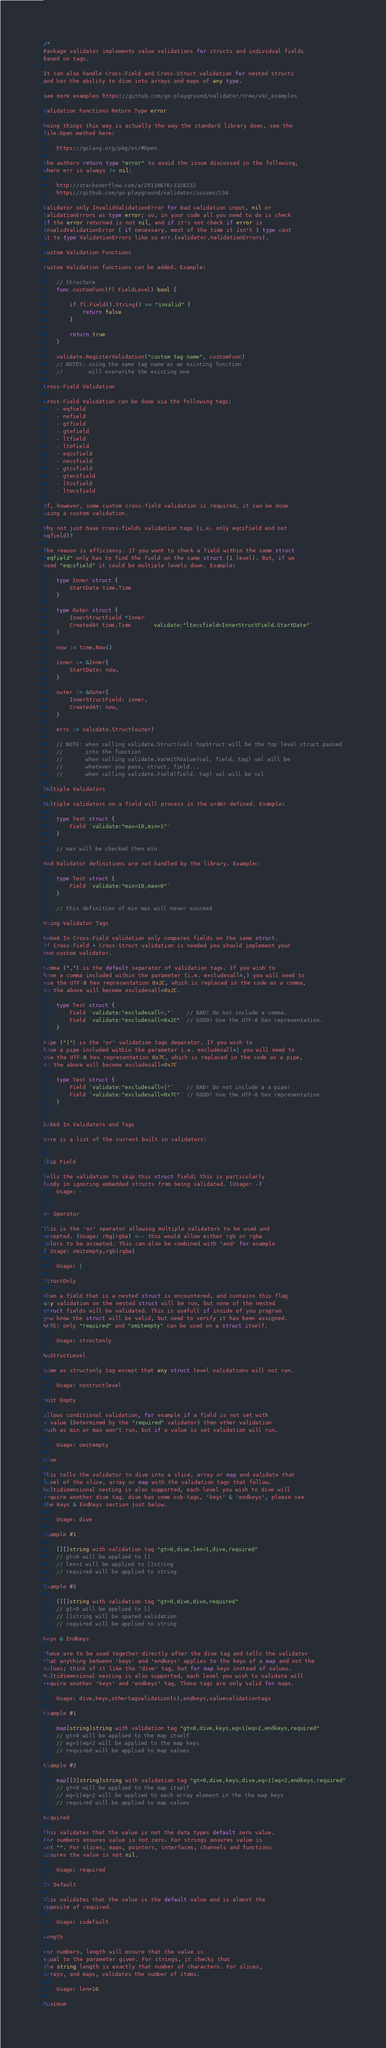<code> <loc_0><loc_0><loc_500><loc_500><_Go_>/*
Package validator implements value validations for structs and individual fields
based on tags.

It can also handle Cross-Field and Cross-Struct validation for nested structs
and has the ability to dive into arrays and maps of any type.

see more examples https://github.com/go-playground/validator/tree/v9/_examples

Validation Functions Return Type error

Doing things this way is actually the way the standard library does, see the
file.Open method here:

	https://golang.org/pkg/os/#Open.

The authors return type "error" to avoid the issue discussed in the following,
where err is always != nil:

	http://stackoverflow.com/a/29138676/3158232
	https://github.com/go-playground/validator/issues/134

Validator only InvalidValidationError for bad validation input, nil or
ValidationErrors as type error; so, in your code all you need to do is check
if the error returned is not nil, and if it's not check if error is
InvalidValidationError ( if necessary, most of the time it isn't ) type cast
it to type ValidationErrors like so err.(validator.ValidationErrors).

Custom Validation Functions

Custom Validation functions can be added. Example:

	// Structure
	func customFunc(fl FieldLevel) bool {

		if fl.Field().String() == "invalid" {
			return false
		}

		return true
	}

	validate.RegisterValidation("custom tag name", customFunc)
	// NOTES: using the same tag name as an existing function
	//        will overwrite the existing one

Cross-Field Validation

Cross-Field Validation can be done via the following tags:
	- eqfield
	- nefield
	- gtfield
	- gtefield
	- ltfield
	- ltefield
	- eqcsfield
	- necsfield
	- gtcsfield
	- gtecsfield
	- ltcsfield
	- ltecsfield

If, however, some custom cross-field validation is required, it can be done
using a custom validation.

Why not just have cross-fields validation tags (i.e. only eqcsfield and not
eqfield)?

The reason is efficiency. If you want to check a field within the same struct
"eqfield" only has to find the field on the same struct (1 level). But, if we
used "eqcsfield" it could be multiple levels down. Example:

	type Inner struct {
		StartDate time.Time
	}

	type Outer struct {
		InnerStructField *Inner
		CreatedAt time.Time      `validate:"ltecsfield=InnerStructField.StartDate"`
	}

	now := time.Now()

	inner := &Inner{
		StartDate: now,
	}

	outer := &Outer{
		InnerStructField: inner,
		CreatedAt: now,
	}

	errs := validate.Struct(outer)

	// NOTE: when calling validate.Struct(val) topStruct will be the top level struct passed
	//       into the function
	//       when calling validate.VarWithValue(val, field, tag) val will be
	//       whatever you pass, struct, field...
	//       when calling validate.Field(field, tag) val will be nil

Multiple Validators

Multiple validators on a field will process in the order defined. Example:

	type Test struct {
		Field `validate:"max=10,min=1"`
	}

	// max will be checked then min

Bad Validator definitions are not handled by the library. Example:

	type Test struct {
		Field `validate:"min=10,max=0"`
	}

	// this definition of min max will never succeed

Using Validator Tags

Baked In Cross-Field validation only compares fields on the same struct.
If Cross-Field + Cross-Struct validation is needed you should implement your
own custom validator.

Comma (",") is the default separator of validation tags. If you wish to
have a comma included within the parameter (i.e. excludesall=,) you will need to
use the UTF-8 hex representation 0x2C, which is replaced in the code as a comma,
so the above will become excludesall=0x2C.

	type Test struct {
		Field `validate:"excludesall=,"`    // BAD! Do not include a comma.
		Field `validate:"excludesall=0x2C"` // GOOD! Use the UTF-8 hex representation.
	}

Pipe ("|") is the 'or' validation tags deparator. If you wish to
have a pipe included within the parameter i.e. excludesall=| you will need to
use the UTF-8 hex representation 0x7C, which is replaced in the code as a pipe,
so the above will become excludesall=0x7C

	type Test struct {
		Field `validate:"excludesall=|"`    // BAD! Do not include a a pipe!
		Field `validate:"excludesall=0x7C"` // GOOD! Use the UTF-8 hex representation.
	}


Baked In Validators and Tags

Here is a list of the current built in validators:


Skip Field

Tells the validation to skip this struct field; this is particularly
handy in ignoring embedded structs from being validated. (Usage: -)
	Usage: -


Or Operator

This is the 'or' operator allowing multiple validators to be used and
accepted. (Usage: rbg|rgba) <-- this would allow either rgb or rgba
colors to be accepted. This can also be combined with 'and' for example
( Usage: omitempty,rgb|rgba)

	Usage: |

StructOnly

When a field that is a nested struct is encountered, and contains this flag
any validation on the nested struct will be run, but none of the nested
struct fields will be validated. This is usefull if inside of you program
you know the struct will be valid, but need to verify it has been assigned.
NOTE: only "required" and "omitempty" can be used on a struct itself.

	Usage: structonly

NoStructLevel

Same as structonly tag except that any struct level validations will not run.

	Usage: nostructlevel

Omit Empty

Allows conditional validation, for example if a field is not set with
a value (Determined by the "required" validator) then other validation
such as min or max won't run, but if a value is set validation will run.

	Usage: omitempty

Dive

This tells the validator to dive into a slice, array or map and validate that
level of the slice, array or map with the validation tags that follow.
Multidimensional nesting is also supported, each level you wish to dive will
require another dive tag. dive has some sub-tags, 'keys' & 'endkeys', please see
the Keys & EndKeys section just below.

	Usage: dive

Example #1

	[][]string with validation tag "gt=0,dive,len=1,dive,required"
	// gt=0 will be applied to []
	// len=1 will be applied to []string
	// required will be applied to string

Example #2

	[][]string with validation tag "gt=0,dive,dive,required"
	// gt=0 will be applied to []
	// []string will be spared validation
	// required will be applied to string

Keys & EndKeys

These are to be used together directly after the dive tag and tells the validator
that anything between 'keys' and 'endkeys' applies to the keys of a map and not the
values; think of it like the 'dive' tag, but for map keys instead of values.
Multidimensional nesting is also supported, each level you wish to validate will
require another 'keys' and 'endkeys' tag. These tags are only valid for maps.

	Usage: dive,keys,othertagvalidation(s),endkeys,valuevalidationtags

Example #1

	map[string]string with validation tag "gt=0,dive,keys,eg=1|eq=2,endkeys,required"
	// gt=0 will be applied to the map itself
	// eg=1|eq=2 will be applied to the map keys
	// required will be applied to map values

Example #2

	map[[2]string]string with validation tag "gt=0,dive,keys,dive,eq=1|eq=2,endkeys,required"
	// gt=0 will be applied to the map itself
	// eg=1|eq=2 will be applied to each array element in the the map keys
	// required will be applied to map values

Required

This validates that the value is not the data types default zero value.
For numbers ensures value is not zero. For strings ensures value is
not "". For slices, maps, pointers, interfaces, channels and functions
ensures the value is not nil.

	Usage: required

Is Default

This validates that the value is the default value and is almost the
opposite of required.

	Usage: isdefault

Length

For numbers, length will ensure that the value is
equal to the parameter given. For strings, it checks that
the string length is exactly that number of characters. For slices,
arrays, and maps, validates the number of items.

	Usage: len=10

Maximum
</code> 